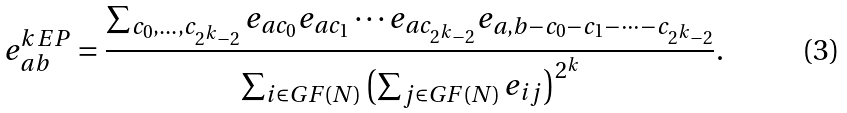Convert formula to latex. <formula><loc_0><loc_0><loc_500><loc_500>e _ { a b } ^ { k \, E P } = \frac { \sum _ { c _ { 0 } , \dots , c _ { 2 ^ { k } - 2 } } e _ { a c _ { 0 } } e _ { a c _ { 1 } } \cdots e _ { a c _ { 2 ^ { k } - 2 } } e _ { a , b - c _ { 0 } - c _ { 1 } - \cdots - c _ { 2 ^ { k } - 2 } } } { \sum _ { i \in G F ( N ) } \left ( \sum _ { j \in G F ( N ) } e _ { i j } \right ) ^ { 2 ^ { k } } } .</formula> 